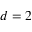Convert formula to latex. <formula><loc_0><loc_0><loc_500><loc_500>d = 2</formula> 